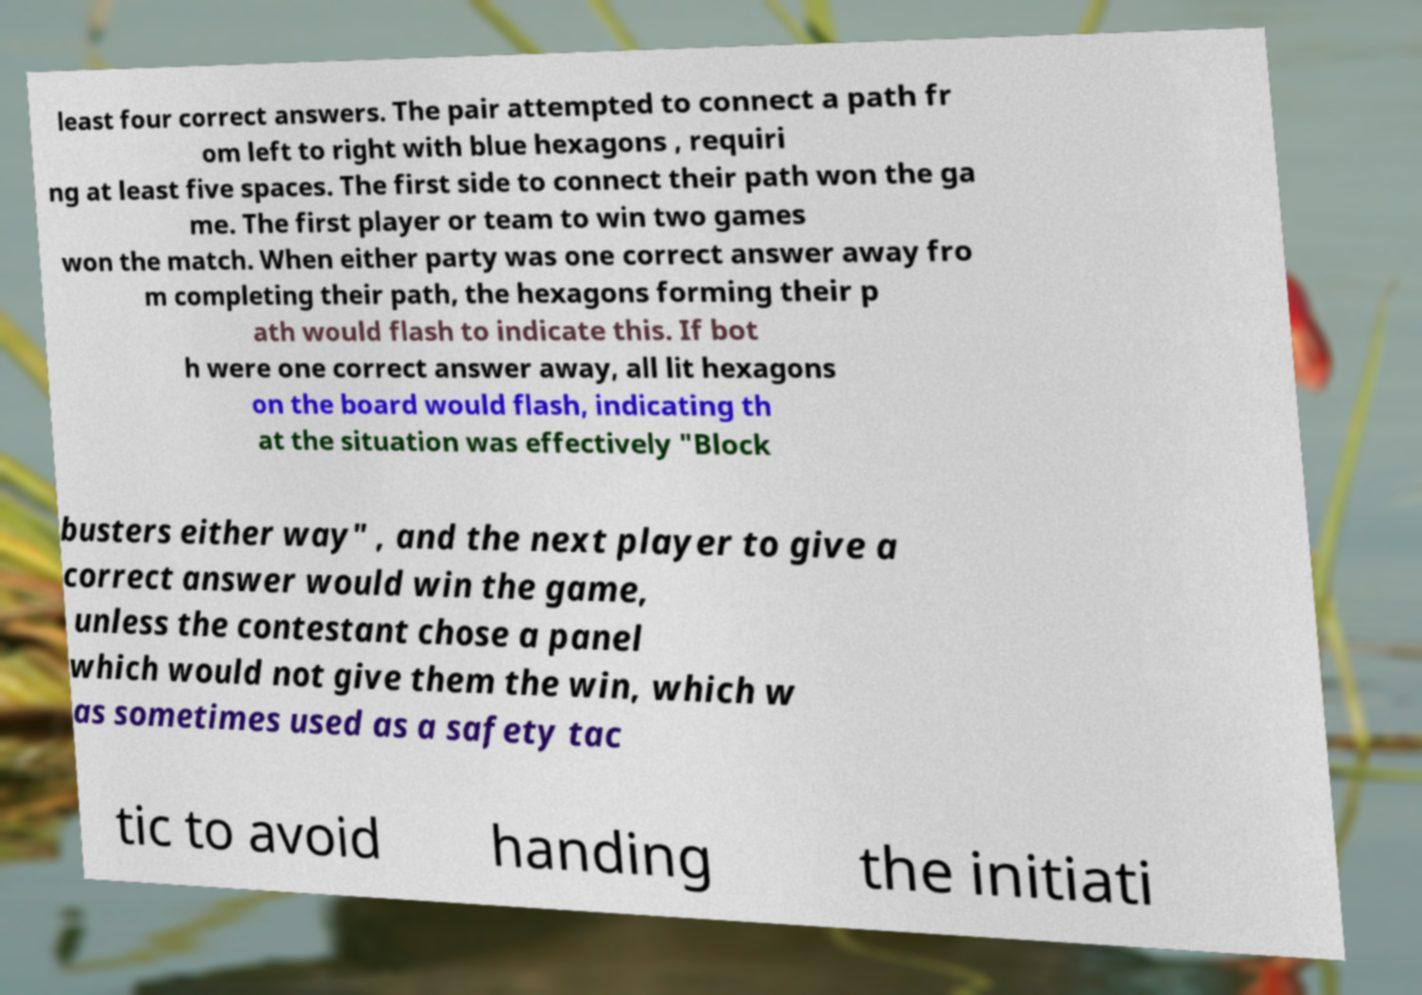Could you extract and type out the text from this image? least four correct answers. The pair attempted to connect a path fr om left to right with blue hexagons , requiri ng at least five spaces. The first side to connect their path won the ga me. The first player or team to win two games won the match. When either party was one correct answer away fro m completing their path, the hexagons forming their p ath would flash to indicate this. If bot h were one correct answer away, all lit hexagons on the board would flash, indicating th at the situation was effectively "Block busters either way" , and the next player to give a correct answer would win the game, unless the contestant chose a panel which would not give them the win, which w as sometimes used as a safety tac tic to avoid handing the initiati 